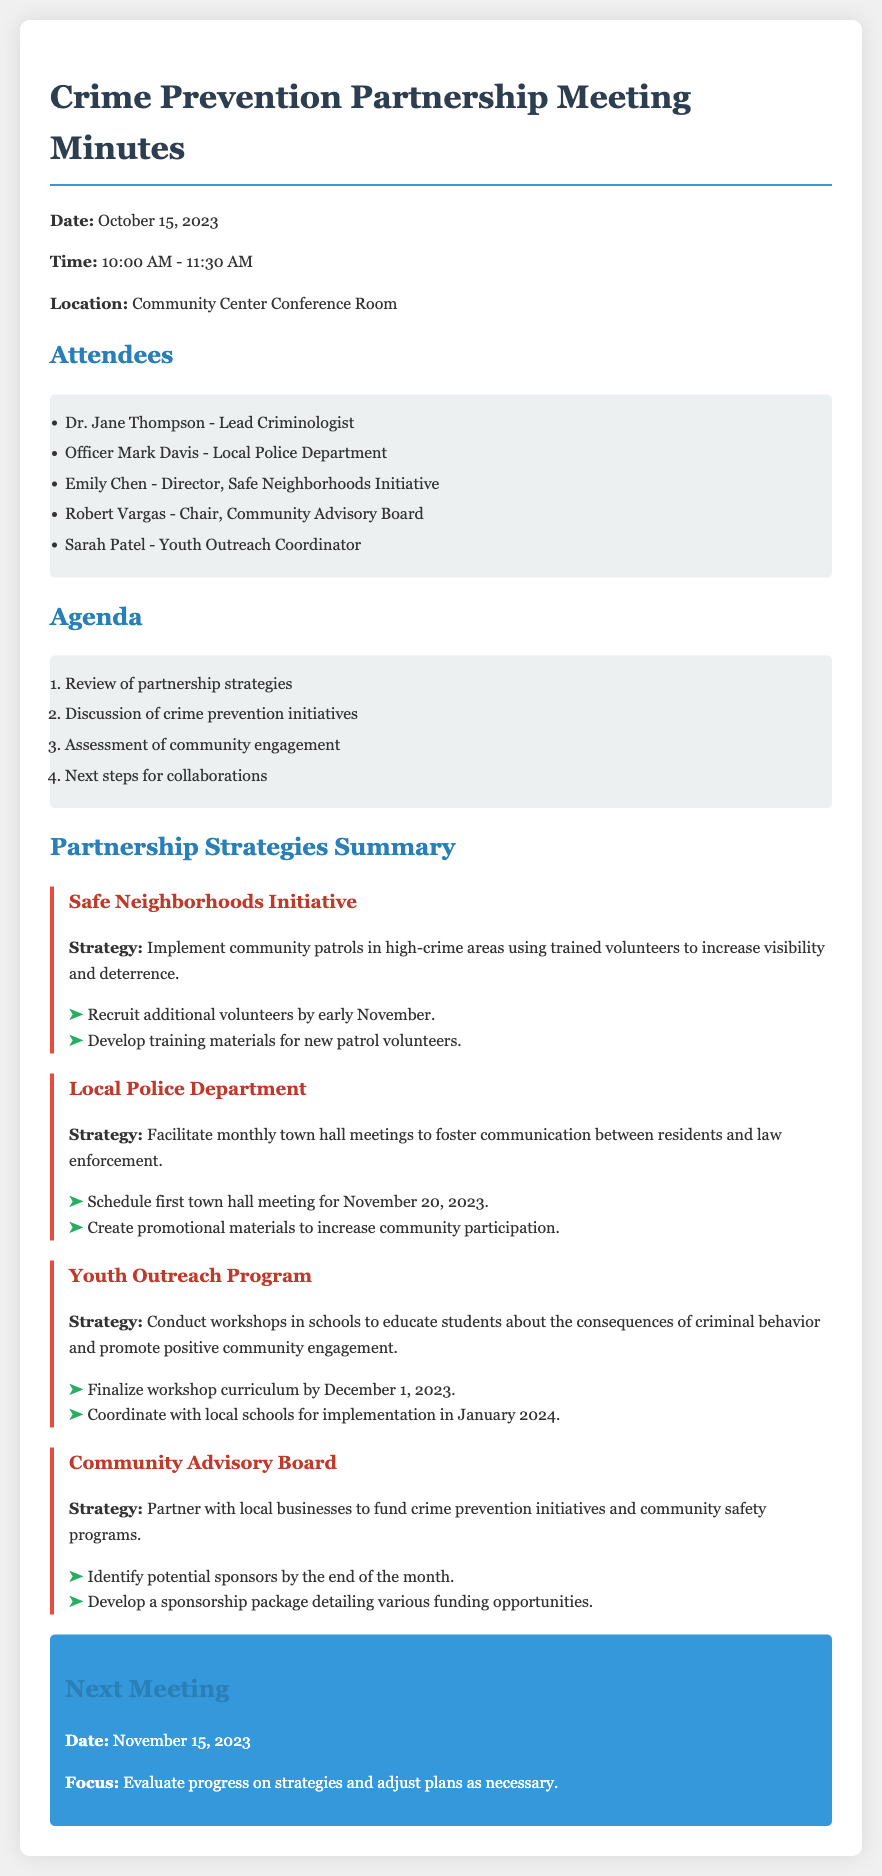What is the date of the meeting? The date of the meeting is mentioned at the beginning of the document.
Answer: October 15, 2023 Who is the Lead Criminologist? The name of the Lead Criminologist is listed in the attendees section.
Answer: Dr. Jane Thompson What is the strategy for the Safe Neighborhoods Initiative? The strategy is detailed under the Safe Neighborhoods Initiative section in the document.
Answer: Implement community patrols in high-crime areas using trained volunteers to increase visibility and deterrence When is the first town hall meeting scheduled? The date for the first town hall meeting is found within the Local Police Department strategy.
Answer: November 20, 2023 What is the focus of the next meeting? The focus for the next meeting is specified at the end of the document.
Answer: Evaluate progress on strategies and adjust plans as necessary How many attendees are listed? The number of attendees can be counted from the attendees section of the document.
Answer: Five What is the deadline to finalize the workshop curriculum? The deadline is stated under the Youth Outreach Program strategy in the document.
Answer: December 1, 2023 What is the objective of the Community Advisory Board's strategy? The objective is summarized under the Community Advisory Board strategy section.
Answer: Partner with local businesses to fund crime prevention initiatives and community safety programs 